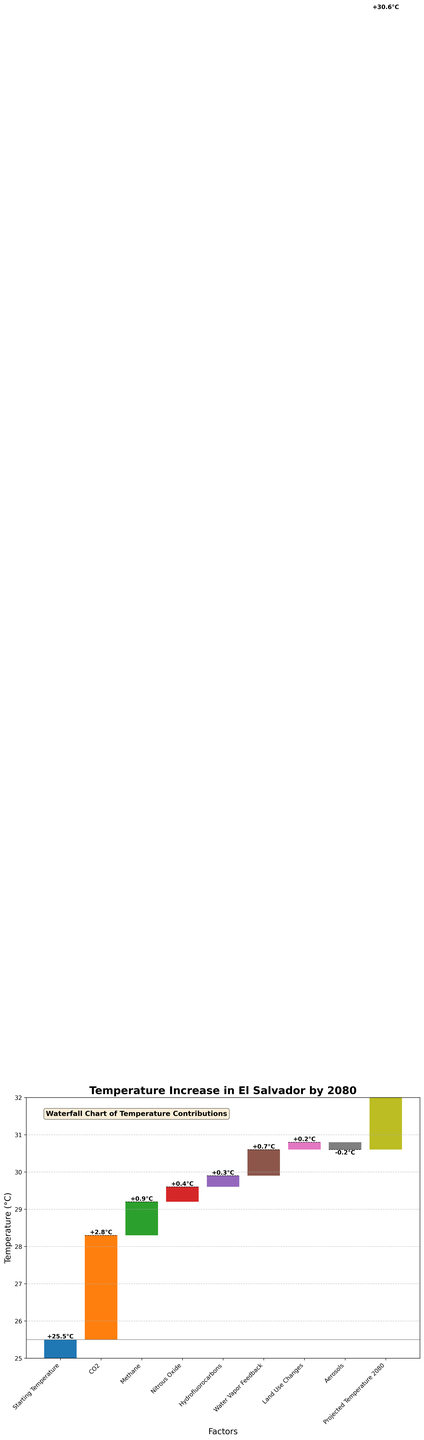What is the starting temperature in the chart? The starting temperature is indicated by the first bar in the waterfall chart, shown as "Starting Temperature" which has a value noted at 25.5°C.
Answer: 25.5°C How much does CO2 contribute to the temperature increase? The contribution from CO2 is represented by the second bar in the chart, listed as "CO2" with an incremental value of 2.8°C.
Answer: 2.8°C What is the projected temperature in El Salvador by 2080? The final cumulative temperature, shown as the last bar labeled "Projected Temperature 2080", is noted as 30.6°C.
Answer: 30.6°C Which factor contributes the most to the temperature increase? By comparing the incremental temperature increases from each factor, CO2 has the highest value at 2.8°C.
Answer: CO2 What is the net effect of aerosols on temperature increase? The contribution from aerosols is depicted as a negative bar in the chart which shows a value of -0.2°C.
Answer: -0.2°C What is the total temperature increase due to all greenhouse gases combined (CO2, Methane, Nitrous Oxide, Hydrofluorocarbons, Water Vapor Feedback)? Add the contributions from CO2 (2.8°C), Methane (0.9°C), Nitrous Oxide (0.4°C), Hydrofluorocarbons (0.3°C), and Water Vapor Feedback (0.7°C). The total increase is 2.8 + 0.9 + 0.4 + 0.3 + 0.7 = 5.1°C.
Answer: 5.1°C How do land use changes affect the temperature increase? The contribution from Land Use Changes is shown as a positive value of 0.2°C in the chart.
Answer: 0.2°C Compare the contributions of Methane and Nitrous Oxide. Which one contributes more to the temperature increase? Methane contributes 0.9°C while Nitrous Oxide contributes 0.4°C. Methane contributes more than Nitrous Oxide.
Answer: Methane What is the cumulative temperature after accounting for aerosols? Starting from 25.5°C, add the intermediate increases to get to the Aerosols' contribution step, then subtract the 0.2°C from Aerosols. The cumulative temperature just before Aerosols is 29.6°C (25.5 + 2.8 + 0.9 + 0.4 + 0.3 + 0.7 + 0.2 - 0.2 = 29.6).
Answer: 29.6°C 